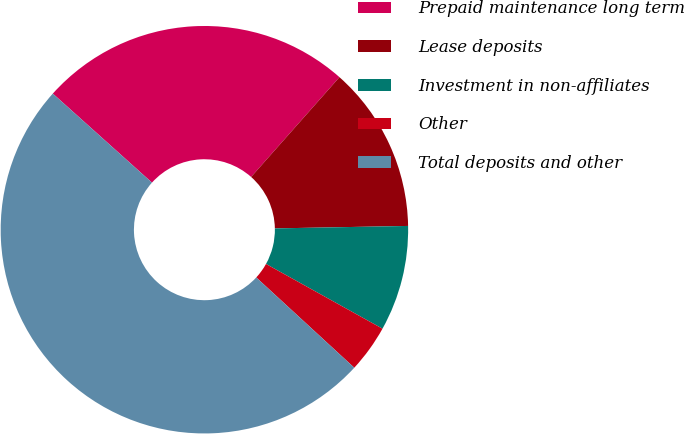Convert chart. <chart><loc_0><loc_0><loc_500><loc_500><pie_chart><fcel>Prepaid maintenance long term<fcel>Lease deposits<fcel>Investment in non-affiliates<fcel>Other<fcel>Total deposits and other<nl><fcel>24.89%<fcel>13.17%<fcel>8.37%<fcel>3.77%<fcel>49.8%<nl></chart> 